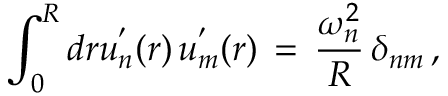Convert formula to latex. <formula><loc_0><loc_0><loc_500><loc_500>\int _ { 0 } ^ { R } d r u _ { n } ^ { ^ { \prime } } ( r ) \, u _ { m } ^ { ^ { \prime } } ( r ) \, = \, \frac { \omega _ { n } ^ { 2 } } { R } \, \delta _ { n m } \, { , }</formula> 